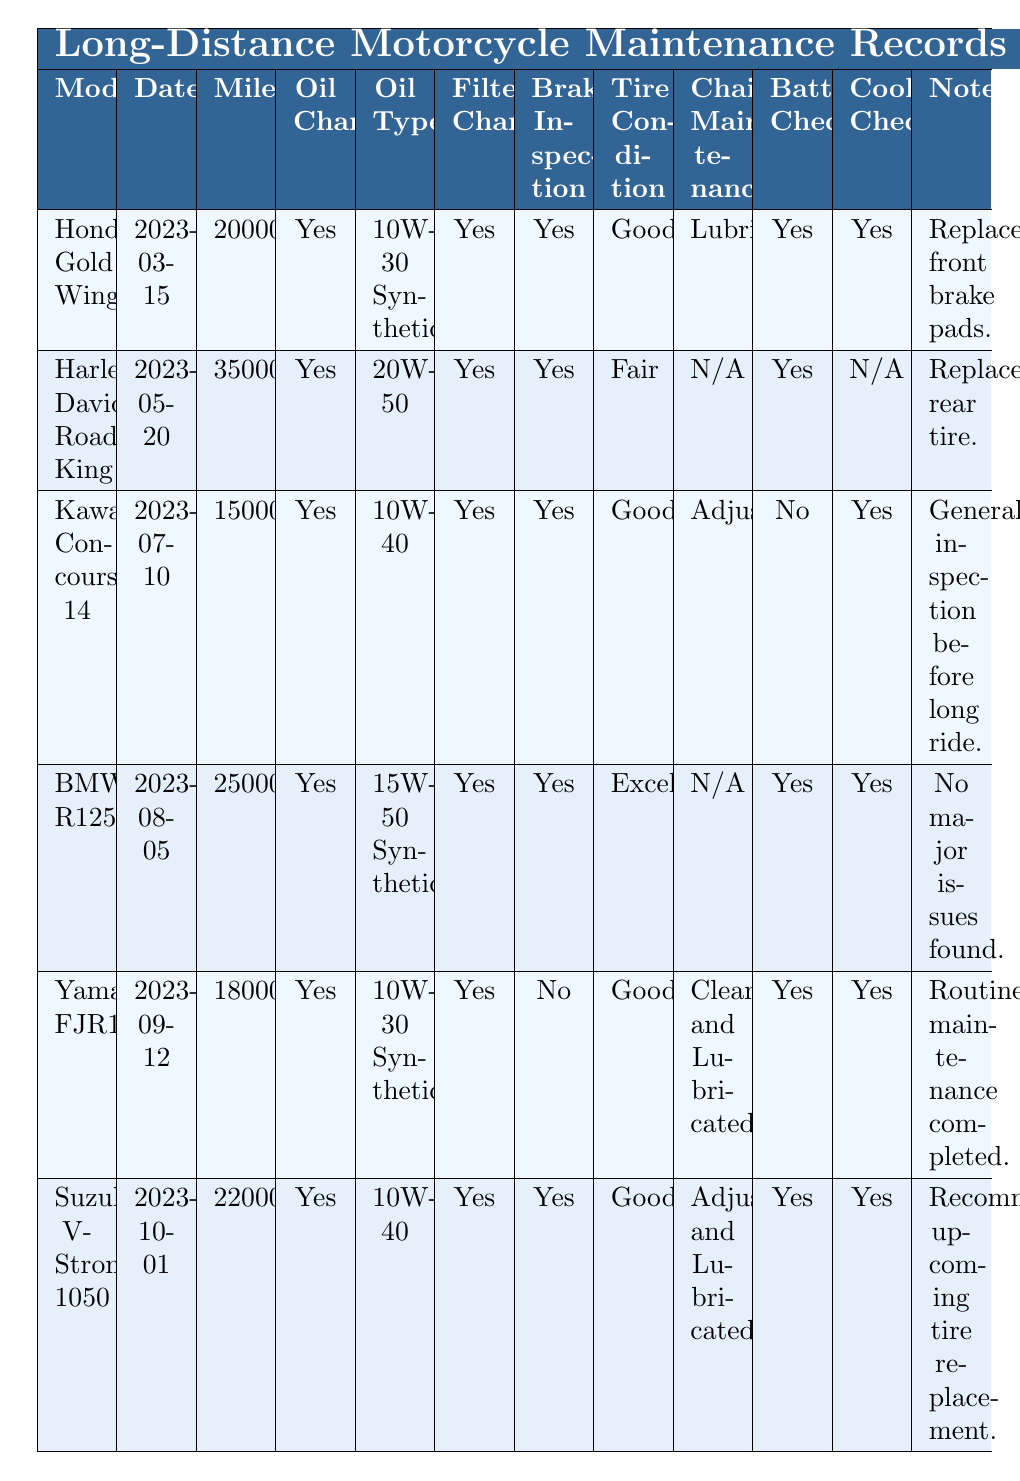What motorcycle model had the latest service date? The latest service date in the table is "2023-10-01", which corresponds to the "Suzuki V-Strom 1050" motorcycle model.
Answer: Suzuki V-Strom 1050 How many motorcycles had a brake inspection marked as "Yes"? By counting the rows in the table, there are 5 motorcycles (Honda Gold Wing, Harley-Davidson Road King, Kawasaki Concours 14, BMW R1250GS, and Suzuki V-Strom 1050) that had a brake inspection marked as "Yes".
Answer: 5 What is the oil type used for the Harley-Davidson Road King? Looking at the specific row for the Harley-Davidson Road King, the oil type is listed as "20W-50".
Answer: 20W-50 Was the battery check completed for the Kawasaki Concours 14? In the table, the battery check for the Kawasaki Concours 14 is marked as "No", indicating it was not completed.
Answer: No Which motorcycle had the highest mileage recorded at service? Reviewing the mileage values in the table, the Harley-Davidson Road King has the highest mileage at 35,000 miles.
Answer: Harley-Davidson Road King What is the average mileage of all the motorcycles recorded? To calculate the average, sum all the mileage values (20000 + 35000 + 15000 + 25000 + 18000 + 22000) = 135000, then divide by the number of motorcycles (6), which gives an average of 22500.
Answer: 22500 Is there any motorcycle that required chain maintenance labeled as "N/A"? By checking the table, both the Harley-Davidson Road King and BMW R1250GS have their chain maintenance status listed as "N/A".
Answer: Yes What specific maintenance step was noted for the Yamaha FJR1300? For the Yamaha FJR1300, it is noted that a routine maintenance was completed.
Answer: Routine maintenance completed Which motorcycle model has the best tire condition, according to the table? The tire condition for the BMW R1250GS is marked as "Excellent", making it the model with the best tire condition.
Answer: BMW R1250GS Was there any motorcycle that did not pass a battery check? From the data, the Kawasaki Concours 14 did not pass the battery check, which is indicated as "No".
Answer: Yes 